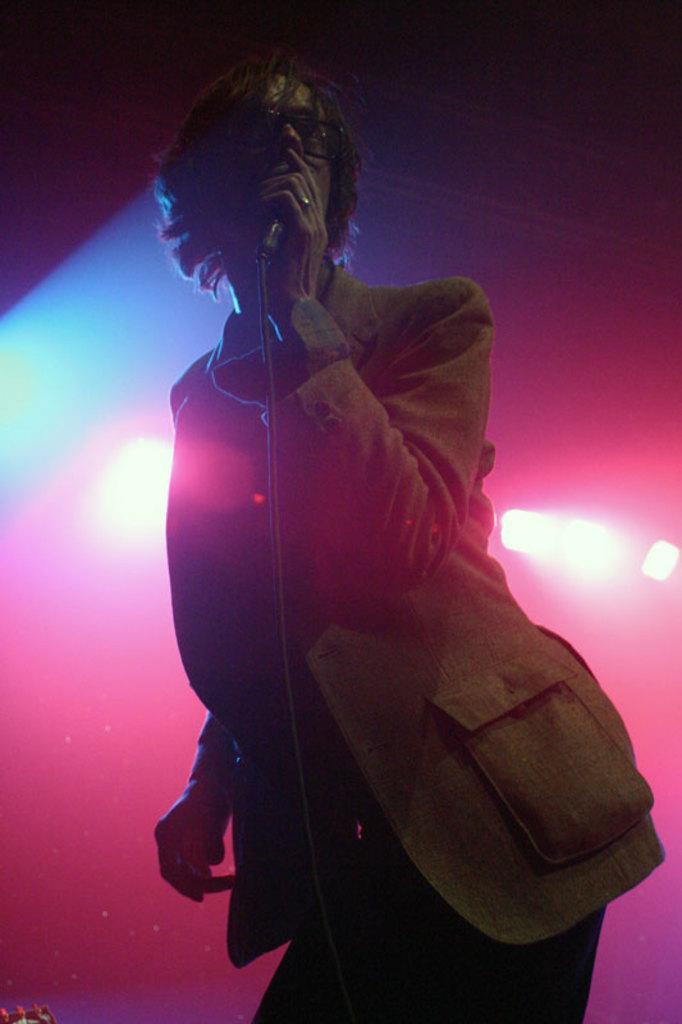Describe this image in one or two sentences. In this image, there is a person wearing clothes and holding a mic with his hand. 